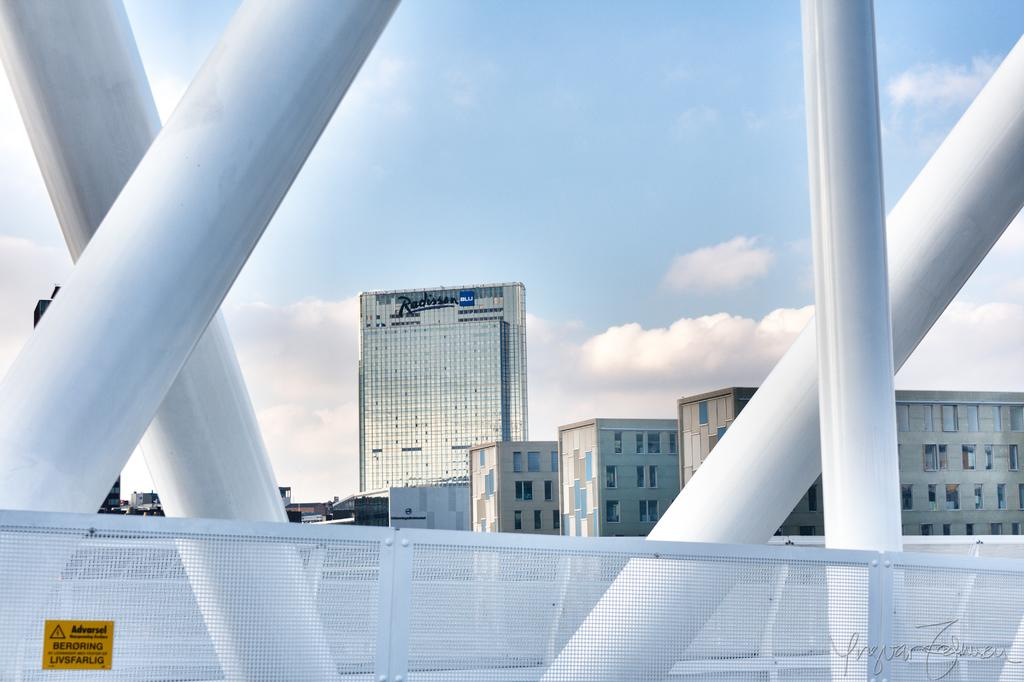<image>
Offer a succinct explanation of the picture presented. The white barrier has a yellow sticker on it that says Advarsel, and there is a Radisson in the background. 